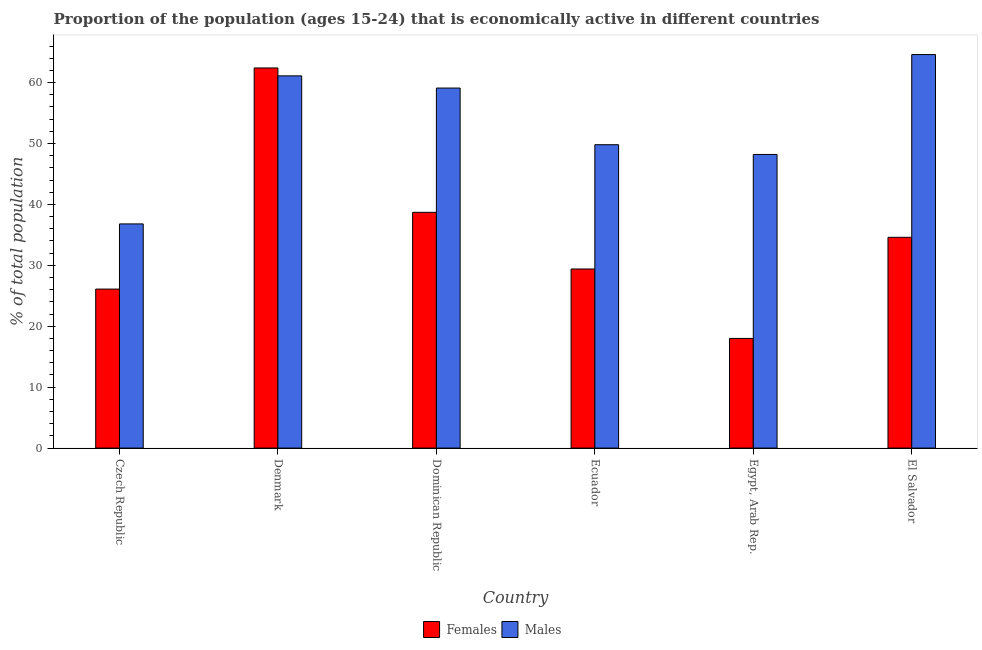How many different coloured bars are there?
Give a very brief answer. 2. How many groups of bars are there?
Offer a very short reply. 6. Are the number of bars on each tick of the X-axis equal?
Offer a terse response. Yes. What is the label of the 2nd group of bars from the left?
Provide a short and direct response. Denmark. What is the percentage of economically active female population in Denmark?
Keep it short and to the point. 62.4. Across all countries, what is the maximum percentage of economically active female population?
Offer a terse response. 62.4. In which country was the percentage of economically active male population maximum?
Keep it short and to the point. El Salvador. In which country was the percentage of economically active male population minimum?
Offer a very short reply. Czech Republic. What is the total percentage of economically active female population in the graph?
Your answer should be very brief. 209.2. What is the difference between the percentage of economically active female population in Ecuador and that in El Salvador?
Your answer should be very brief. -5.2. What is the difference between the percentage of economically active male population in Denmark and the percentage of economically active female population in Czech Republic?
Your response must be concise. 35. What is the average percentage of economically active male population per country?
Your answer should be compact. 53.27. What is the difference between the percentage of economically active male population and percentage of economically active female population in Dominican Republic?
Keep it short and to the point. 20.4. What is the ratio of the percentage of economically active female population in Denmark to that in Dominican Republic?
Ensure brevity in your answer.  1.61. Is the difference between the percentage of economically active male population in Czech Republic and Dominican Republic greater than the difference between the percentage of economically active female population in Czech Republic and Dominican Republic?
Offer a terse response. No. What is the difference between the highest and the second highest percentage of economically active female population?
Ensure brevity in your answer.  23.7. What is the difference between the highest and the lowest percentage of economically active female population?
Ensure brevity in your answer.  44.4. In how many countries, is the percentage of economically active male population greater than the average percentage of economically active male population taken over all countries?
Your response must be concise. 3. Is the sum of the percentage of economically active female population in Denmark and El Salvador greater than the maximum percentage of economically active male population across all countries?
Offer a very short reply. Yes. What does the 1st bar from the left in Egypt, Arab Rep. represents?
Provide a succinct answer. Females. What does the 2nd bar from the right in El Salvador represents?
Offer a very short reply. Females. How many bars are there?
Your answer should be compact. 12. How many countries are there in the graph?
Your answer should be compact. 6. What is the difference between two consecutive major ticks on the Y-axis?
Your answer should be very brief. 10. Does the graph contain grids?
Offer a terse response. No. Where does the legend appear in the graph?
Ensure brevity in your answer.  Bottom center. How many legend labels are there?
Give a very brief answer. 2. What is the title of the graph?
Ensure brevity in your answer.  Proportion of the population (ages 15-24) that is economically active in different countries. Does "Non-resident workers" appear as one of the legend labels in the graph?
Your response must be concise. No. What is the label or title of the Y-axis?
Your answer should be compact. % of total population. What is the % of total population in Females in Czech Republic?
Your answer should be very brief. 26.1. What is the % of total population in Males in Czech Republic?
Provide a short and direct response. 36.8. What is the % of total population of Females in Denmark?
Keep it short and to the point. 62.4. What is the % of total population of Males in Denmark?
Your answer should be compact. 61.1. What is the % of total population of Females in Dominican Republic?
Offer a very short reply. 38.7. What is the % of total population of Males in Dominican Republic?
Provide a short and direct response. 59.1. What is the % of total population in Females in Ecuador?
Offer a terse response. 29.4. What is the % of total population in Males in Ecuador?
Your response must be concise. 49.8. What is the % of total population in Females in Egypt, Arab Rep.?
Keep it short and to the point. 18. What is the % of total population in Males in Egypt, Arab Rep.?
Your response must be concise. 48.2. What is the % of total population in Females in El Salvador?
Provide a short and direct response. 34.6. What is the % of total population in Males in El Salvador?
Offer a terse response. 64.6. Across all countries, what is the maximum % of total population of Females?
Make the answer very short. 62.4. Across all countries, what is the maximum % of total population in Males?
Keep it short and to the point. 64.6. Across all countries, what is the minimum % of total population in Females?
Offer a terse response. 18. Across all countries, what is the minimum % of total population of Males?
Make the answer very short. 36.8. What is the total % of total population in Females in the graph?
Give a very brief answer. 209.2. What is the total % of total population of Males in the graph?
Keep it short and to the point. 319.6. What is the difference between the % of total population in Females in Czech Republic and that in Denmark?
Provide a short and direct response. -36.3. What is the difference between the % of total population in Males in Czech Republic and that in Denmark?
Your response must be concise. -24.3. What is the difference between the % of total population of Males in Czech Republic and that in Dominican Republic?
Ensure brevity in your answer.  -22.3. What is the difference between the % of total population in Females in Czech Republic and that in Ecuador?
Give a very brief answer. -3.3. What is the difference between the % of total population in Males in Czech Republic and that in Egypt, Arab Rep.?
Your response must be concise. -11.4. What is the difference between the % of total population of Males in Czech Republic and that in El Salvador?
Your answer should be very brief. -27.8. What is the difference between the % of total population in Females in Denmark and that in Dominican Republic?
Make the answer very short. 23.7. What is the difference between the % of total population of Males in Denmark and that in Dominican Republic?
Your answer should be very brief. 2. What is the difference between the % of total population in Males in Denmark and that in Ecuador?
Keep it short and to the point. 11.3. What is the difference between the % of total population of Females in Denmark and that in Egypt, Arab Rep.?
Give a very brief answer. 44.4. What is the difference between the % of total population in Males in Denmark and that in Egypt, Arab Rep.?
Make the answer very short. 12.9. What is the difference between the % of total population in Females in Denmark and that in El Salvador?
Provide a succinct answer. 27.8. What is the difference between the % of total population of Males in Denmark and that in El Salvador?
Your response must be concise. -3.5. What is the difference between the % of total population of Females in Dominican Republic and that in Ecuador?
Your answer should be very brief. 9.3. What is the difference between the % of total population of Males in Dominican Republic and that in Ecuador?
Provide a succinct answer. 9.3. What is the difference between the % of total population in Females in Dominican Republic and that in Egypt, Arab Rep.?
Ensure brevity in your answer.  20.7. What is the difference between the % of total population in Males in Dominican Republic and that in Egypt, Arab Rep.?
Offer a very short reply. 10.9. What is the difference between the % of total population of Females in Dominican Republic and that in El Salvador?
Offer a very short reply. 4.1. What is the difference between the % of total population of Males in Dominican Republic and that in El Salvador?
Your answer should be very brief. -5.5. What is the difference between the % of total population in Females in Ecuador and that in Egypt, Arab Rep.?
Your answer should be compact. 11.4. What is the difference between the % of total population of Males in Ecuador and that in El Salvador?
Your answer should be compact. -14.8. What is the difference between the % of total population in Females in Egypt, Arab Rep. and that in El Salvador?
Provide a succinct answer. -16.6. What is the difference between the % of total population in Males in Egypt, Arab Rep. and that in El Salvador?
Provide a short and direct response. -16.4. What is the difference between the % of total population of Females in Czech Republic and the % of total population of Males in Denmark?
Provide a short and direct response. -35. What is the difference between the % of total population in Females in Czech Republic and the % of total population in Males in Dominican Republic?
Keep it short and to the point. -33. What is the difference between the % of total population of Females in Czech Republic and the % of total population of Males in Ecuador?
Provide a short and direct response. -23.7. What is the difference between the % of total population in Females in Czech Republic and the % of total population in Males in Egypt, Arab Rep.?
Give a very brief answer. -22.1. What is the difference between the % of total population of Females in Czech Republic and the % of total population of Males in El Salvador?
Your answer should be compact. -38.5. What is the difference between the % of total population of Females in Denmark and the % of total population of Males in Dominican Republic?
Your answer should be very brief. 3.3. What is the difference between the % of total population of Females in Dominican Republic and the % of total population of Males in Ecuador?
Provide a succinct answer. -11.1. What is the difference between the % of total population in Females in Dominican Republic and the % of total population in Males in El Salvador?
Give a very brief answer. -25.9. What is the difference between the % of total population in Females in Ecuador and the % of total population in Males in Egypt, Arab Rep.?
Keep it short and to the point. -18.8. What is the difference between the % of total population in Females in Ecuador and the % of total population in Males in El Salvador?
Your response must be concise. -35.2. What is the difference between the % of total population of Females in Egypt, Arab Rep. and the % of total population of Males in El Salvador?
Make the answer very short. -46.6. What is the average % of total population of Females per country?
Ensure brevity in your answer.  34.87. What is the average % of total population of Males per country?
Keep it short and to the point. 53.27. What is the difference between the % of total population in Females and % of total population in Males in Dominican Republic?
Provide a short and direct response. -20.4. What is the difference between the % of total population of Females and % of total population of Males in Ecuador?
Provide a succinct answer. -20.4. What is the difference between the % of total population in Females and % of total population in Males in Egypt, Arab Rep.?
Provide a short and direct response. -30.2. What is the difference between the % of total population in Females and % of total population in Males in El Salvador?
Give a very brief answer. -30. What is the ratio of the % of total population in Females in Czech Republic to that in Denmark?
Make the answer very short. 0.42. What is the ratio of the % of total population of Males in Czech Republic to that in Denmark?
Your answer should be compact. 0.6. What is the ratio of the % of total population of Females in Czech Republic to that in Dominican Republic?
Ensure brevity in your answer.  0.67. What is the ratio of the % of total population in Males in Czech Republic to that in Dominican Republic?
Your answer should be very brief. 0.62. What is the ratio of the % of total population of Females in Czech Republic to that in Ecuador?
Your response must be concise. 0.89. What is the ratio of the % of total population of Males in Czech Republic to that in Ecuador?
Keep it short and to the point. 0.74. What is the ratio of the % of total population in Females in Czech Republic to that in Egypt, Arab Rep.?
Keep it short and to the point. 1.45. What is the ratio of the % of total population in Males in Czech Republic to that in Egypt, Arab Rep.?
Your answer should be very brief. 0.76. What is the ratio of the % of total population in Females in Czech Republic to that in El Salvador?
Your response must be concise. 0.75. What is the ratio of the % of total population of Males in Czech Republic to that in El Salvador?
Ensure brevity in your answer.  0.57. What is the ratio of the % of total population in Females in Denmark to that in Dominican Republic?
Your answer should be very brief. 1.61. What is the ratio of the % of total population in Males in Denmark to that in Dominican Republic?
Offer a terse response. 1.03. What is the ratio of the % of total population in Females in Denmark to that in Ecuador?
Your answer should be compact. 2.12. What is the ratio of the % of total population in Males in Denmark to that in Ecuador?
Provide a short and direct response. 1.23. What is the ratio of the % of total population of Females in Denmark to that in Egypt, Arab Rep.?
Provide a short and direct response. 3.47. What is the ratio of the % of total population of Males in Denmark to that in Egypt, Arab Rep.?
Your answer should be compact. 1.27. What is the ratio of the % of total population in Females in Denmark to that in El Salvador?
Provide a succinct answer. 1.8. What is the ratio of the % of total population in Males in Denmark to that in El Salvador?
Your response must be concise. 0.95. What is the ratio of the % of total population in Females in Dominican Republic to that in Ecuador?
Your answer should be very brief. 1.32. What is the ratio of the % of total population of Males in Dominican Republic to that in Ecuador?
Offer a very short reply. 1.19. What is the ratio of the % of total population of Females in Dominican Republic to that in Egypt, Arab Rep.?
Your response must be concise. 2.15. What is the ratio of the % of total population of Males in Dominican Republic to that in Egypt, Arab Rep.?
Your answer should be very brief. 1.23. What is the ratio of the % of total population of Females in Dominican Republic to that in El Salvador?
Provide a short and direct response. 1.12. What is the ratio of the % of total population in Males in Dominican Republic to that in El Salvador?
Give a very brief answer. 0.91. What is the ratio of the % of total population of Females in Ecuador to that in Egypt, Arab Rep.?
Give a very brief answer. 1.63. What is the ratio of the % of total population in Males in Ecuador to that in Egypt, Arab Rep.?
Offer a very short reply. 1.03. What is the ratio of the % of total population in Females in Ecuador to that in El Salvador?
Ensure brevity in your answer.  0.85. What is the ratio of the % of total population of Males in Ecuador to that in El Salvador?
Your answer should be very brief. 0.77. What is the ratio of the % of total population in Females in Egypt, Arab Rep. to that in El Salvador?
Keep it short and to the point. 0.52. What is the ratio of the % of total population in Males in Egypt, Arab Rep. to that in El Salvador?
Ensure brevity in your answer.  0.75. What is the difference between the highest and the second highest % of total population in Females?
Provide a short and direct response. 23.7. What is the difference between the highest and the second highest % of total population in Males?
Give a very brief answer. 3.5. What is the difference between the highest and the lowest % of total population of Females?
Offer a very short reply. 44.4. What is the difference between the highest and the lowest % of total population of Males?
Your answer should be very brief. 27.8. 